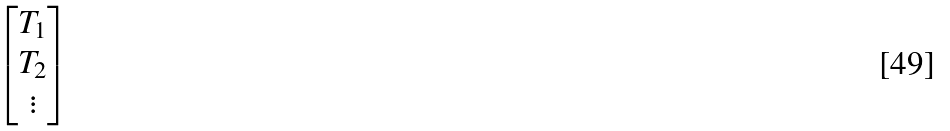Convert formula to latex. <formula><loc_0><loc_0><loc_500><loc_500>\begin{bmatrix} T _ { 1 } \\ T _ { 2 } \\ \vdots \end{bmatrix}</formula> 